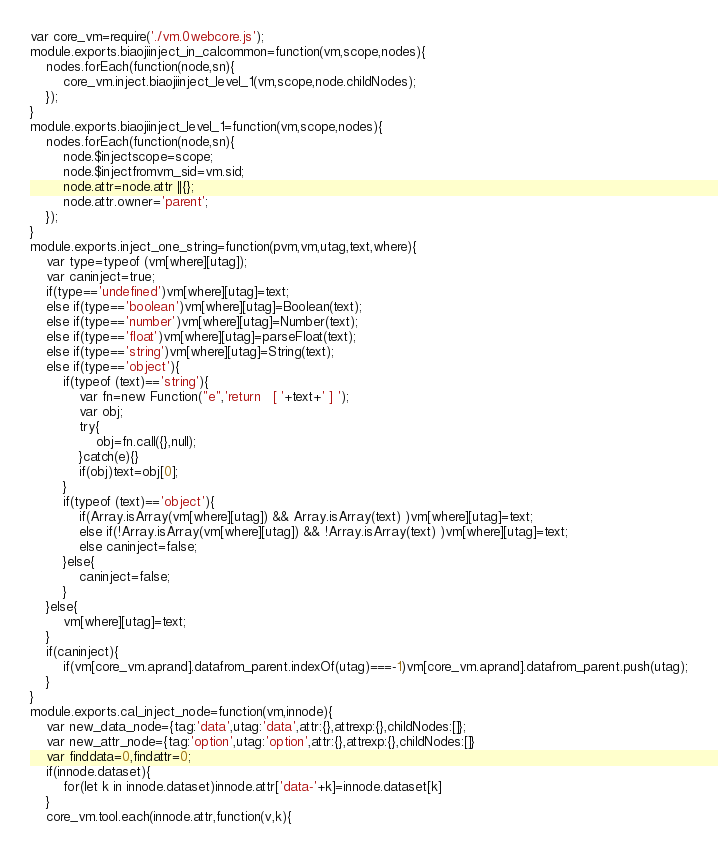<code> <loc_0><loc_0><loc_500><loc_500><_JavaScript_>var core_vm=require('./vm.0webcore.js');
module.exports.biaojiinject_in_calcommon=function(vm,scope,nodes){
	nodes.forEach(function(node,sn){
		core_vm.inject.biaojiinject_level_1(vm,scope,node.childNodes);
	});
}
module.exports.biaojiinject_level_1=function(vm,scope,nodes){
	nodes.forEach(function(node,sn){
		node.$injectscope=scope;
		node.$injectfromvm_sid=vm.sid;
		node.attr=node.attr ||{};
		node.attr.owner='parent';
	});
}
module.exports.inject_one_string=function(pvm,vm,utag,text,where){
	var type=typeof (vm[where][utag]);
	var caninject=true;
	if(type=='undefined')vm[where][utag]=text;
	else if(type=='boolean')vm[where][utag]=Boolean(text);
	else if(type=='number')vm[where][utag]=Number(text);
	else if(type=='float')vm[where][utag]=parseFloat(text);
	else if(type=='string')vm[where][utag]=String(text);
	else if(type=='object'){
		if(typeof (text)=='string'){
			var fn=new Function("e",'return   [ '+text+' ] ');
			var obj;
			try{
				obj=fn.call({},null);
			}catch(e){}
			if(obj)text=obj[0];
		}
		if(typeof (text)=='object'){
			if(Array.isArray(vm[where][utag]) && Array.isArray(text) )vm[where][utag]=text;
			else if(!Array.isArray(vm[where][utag]) && !Array.isArray(text) )vm[where][utag]=text;
			else caninject=false;
		}else{
			caninject=false;
		}
	}else{
		vm[where][utag]=text;
	}
	if(caninject){
		if(vm[core_vm.aprand].datafrom_parent.indexOf(utag)===-1)vm[core_vm.aprand].datafrom_parent.push(utag);
	}
}
module.exports.cal_inject_node=function(vm,innode){
	var new_data_node={tag:'data',utag:'data',attr:{},attrexp:{},childNodes:[]};
	var new_attr_node={tag:'option',utag:'option',attr:{},attrexp:{},childNodes:[]}
	var finddata=0,findattr=0;
	if(innode.dataset){
		for(let k in innode.dataset)innode.attr['data-'+k]=innode.dataset[k]
	}
	core_vm.tool.each(innode.attr,function(v,k){</code> 